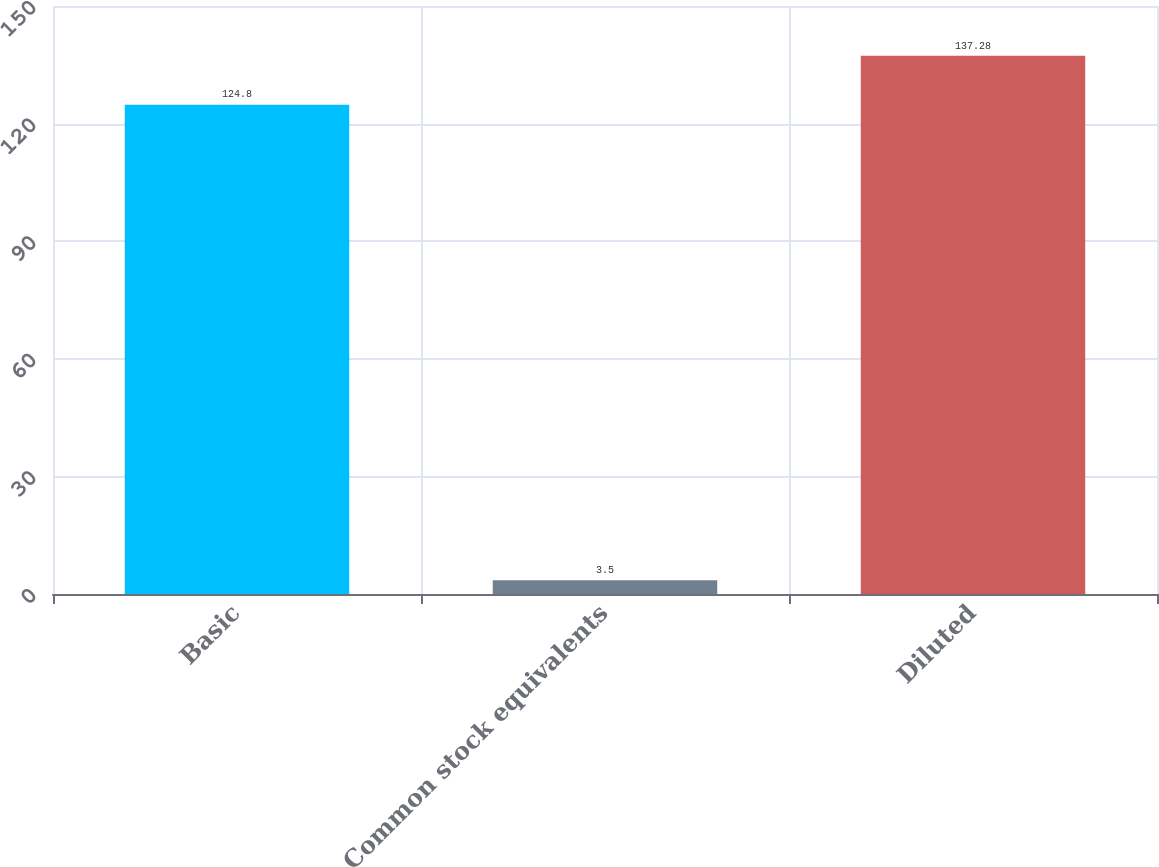<chart> <loc_0><loc_0><loc_500><loc_500><bar_chart><fcel>Basic<fcel>Common stock equivalents<fcel>Diluted<nl><fcel>124.8<fcel>3.5<fcel>137.28<nl></chart> 